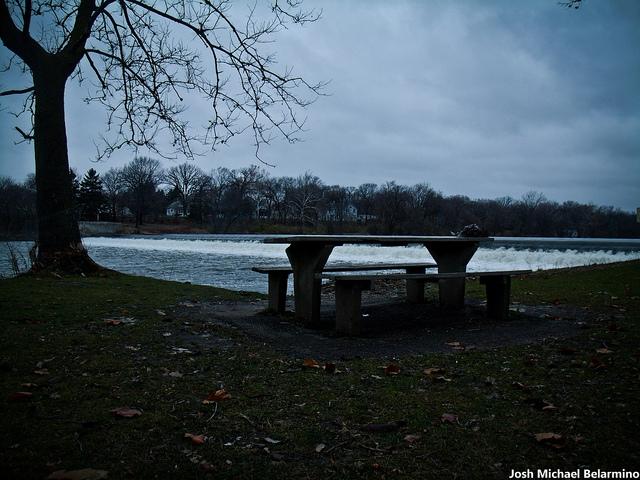What time of day is it?
Be succinct. Evening. What is the bench made out of?
Answer briefly. Wood. Judging by the leaves falling, what season is it?
Concise answer only. Fall. What is this bench made out of?
Short answer required. Wood. What time of day is depicted in this photograph?
Write a very short answer. Evening. Is that a ghost on the bench?
Quick response, please. No. Are any of the structures in the picture man made?
Keep it brief. Yes. How many trees show roots?
Give a very brief answer. 1. What time of day do you think this is?
Keep it brief. Evening. Is there a bench in the picture?
Write a very short answer. Yes. Is the bench between 2 trees?
Answer briefly. No. 